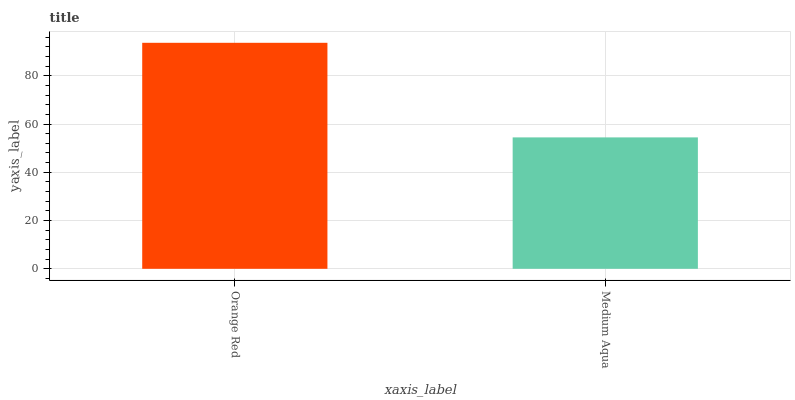Is Medium Aqua the minimum?
Answer yes or no. Yes. Is Orange Red the maximum?
Answer yes or no. Yes. Is Medium Aqua the maximum?
Answer yes or no. No. Is Orange Red greater than Medium Aqua?
Answer yes or no. Yes. Is Medium Aqua less than Orange Red?
Answer yes or no. Yes. Is Medium Aqua greater than Orange Red?
Answer yes or no. No. Is Orange Red less than Medium Aqua?
Answer yes or no. No. Is Orange Red the high median?
Answer yes or no. Yes. Is Medium Aqua the low median?
Answer yes or no. Yes. Is Medium Aqua the high median?
Answer yes or no. No. Is Orange Red the low median?
Answer yes or no. No. 